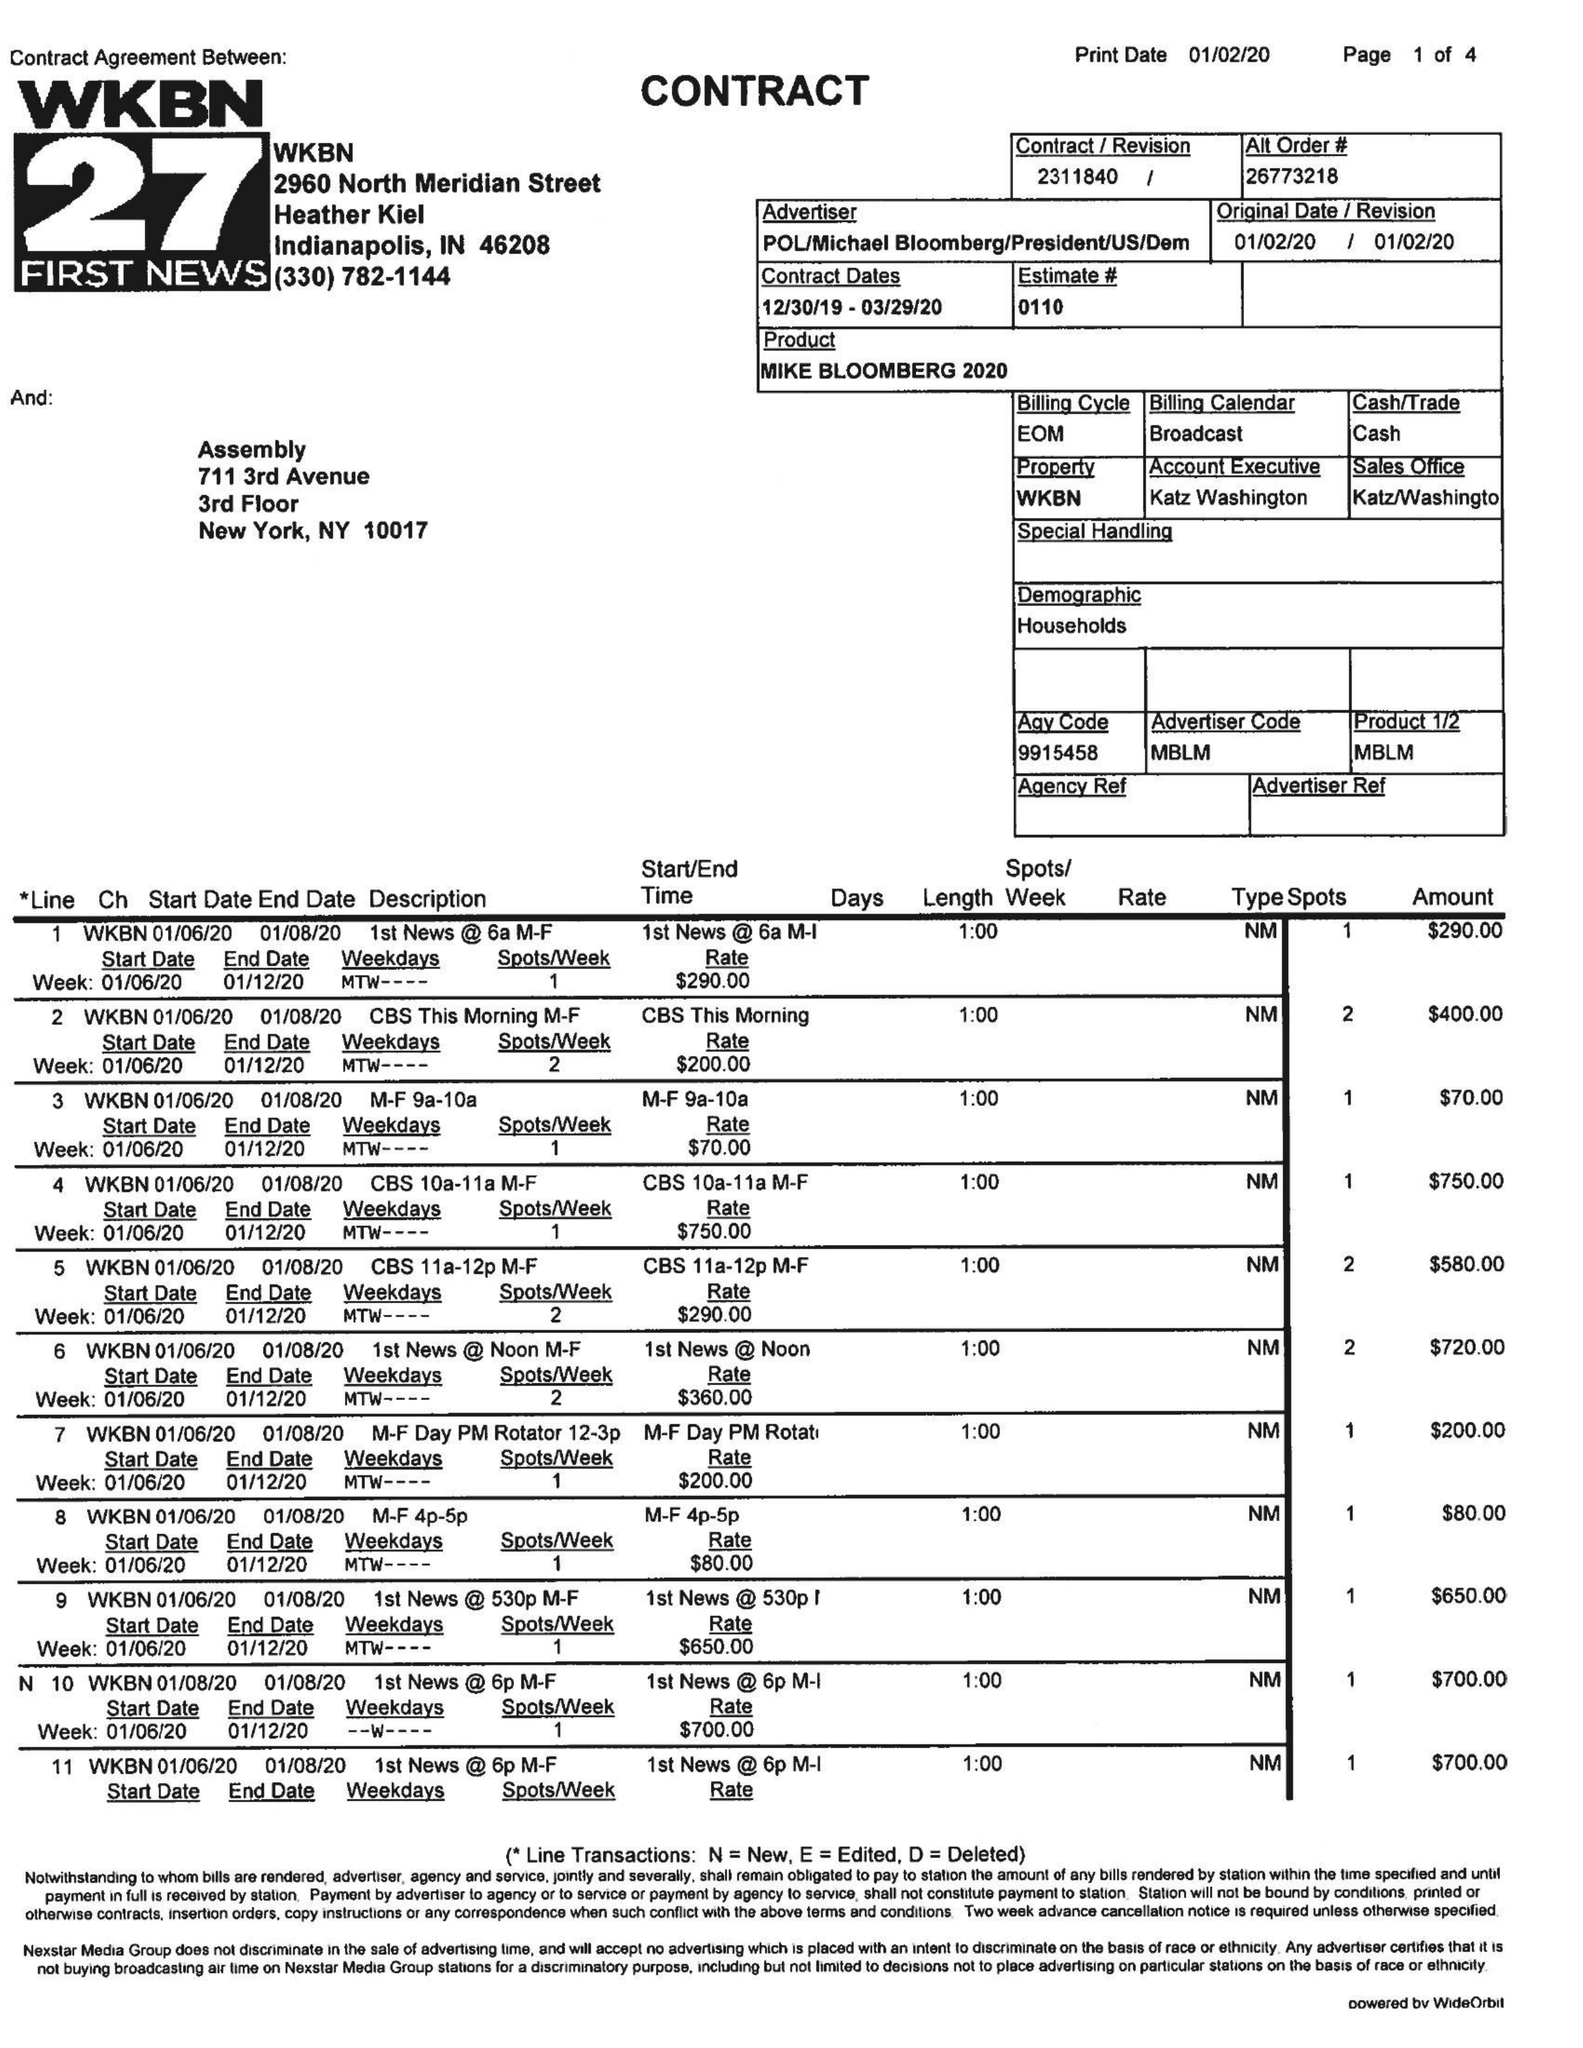What is the value for the flight_from?
Answer the question using a single word or phrase. 12/30/19 